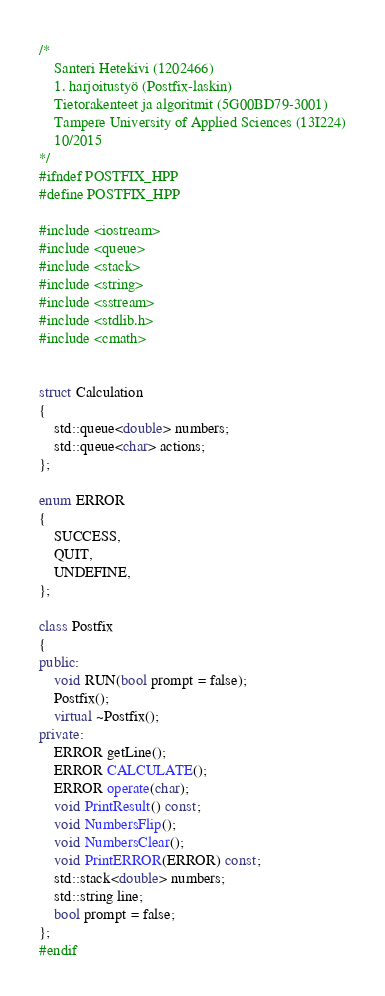Convert code to text. <code><loc_0><loc_0><loc_500><loc_500><_C++_>/*	
	Santeri Hetekivi (1202466)
	1. harjoitustyö (Postfix-laskin)
	Tietorakenteet ja algoritmit (5G00BD79-3001)
	Tampere University of Applied Sciences (13I224)
	10/2015
*/
#ifndef POSTFIX_HPP
#define POSTFIX_HPP

#include <iostream>
#include <queue>
#include <stack>
#include <string>
#include <sstream>
#include <stdlib.h>
#include <cmath>


struct Calculation
{
	std::queue<double> numbers;
	std::queue<char> actions;
};

enum ERROR
{
	SUCCESS,
	QUIT,
	UNDEFINE,
};

class Postfix
{
public:
	void RUN(bool prompt = false);
	Postfix();
	virtual ~Postfix();
private:
	ERROR getLine();
	ERROR CALCULATE();
	ERROR operate(char);
	void PrintResult() const;
	void NumbersFlip();
	void NumbersClear();
	void PrintERROR(ERROR) const;
	std::stack<double> numbers;
	std::string line;
	bool prompt = false;
};
#endif
</code> 